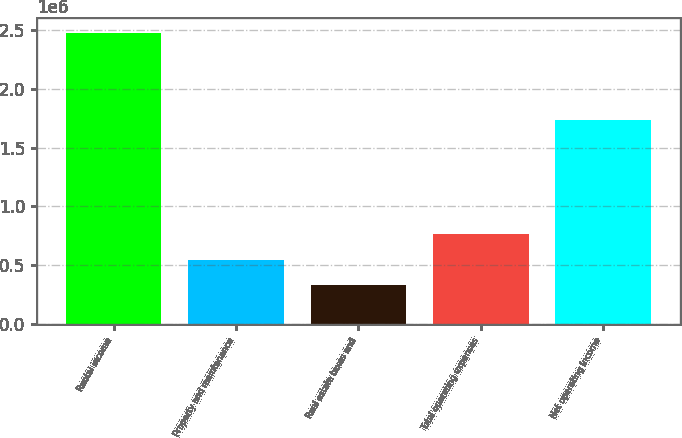Convert chart. <chart><loc_0><loc_0><loc_500><loc_500><bar_chart><fcel>Rental income<fcel>Property and maintenance<fcel>Real estate taxes and<fcel>Total operating expenses<fcel>Net operating income<nl><fcel>2.47069e+06<fcel>549014<fcel>335495<fcel>762534<fcel>1.72991e+06<nl></chart> 